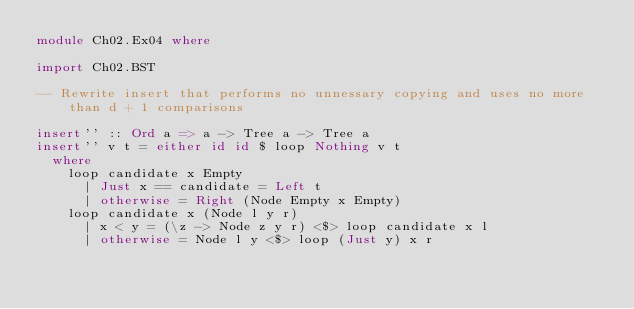<code> <loc_0><loc_0><loc_500><loc_500><_Haskell_>module Ch02.Ex04 where

import Ch02.BST

-- Rewrite insert that performs no unnessary copying and uses no more than d + 1 comparisons

insert'' :: Ord a => a -> Tree a -> Tree a 
insert'' v t = either id id $ loop Nothing v t 
  where
    loop candidate x Empty 
      | Just x == candidate = Left t 
      | otherwise = Right (Node Empty x Empty)
    loop candidate x (Node l y r)
      | x < y = (\z -> Node z y r) <$> loop candidate x l 
      | otherwise = Node l y <$> loop (Just y) x r</code> 